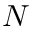Convert formula to latex. <formula><loc_0><loc_0><loc_500><loc_500>N</formula> 